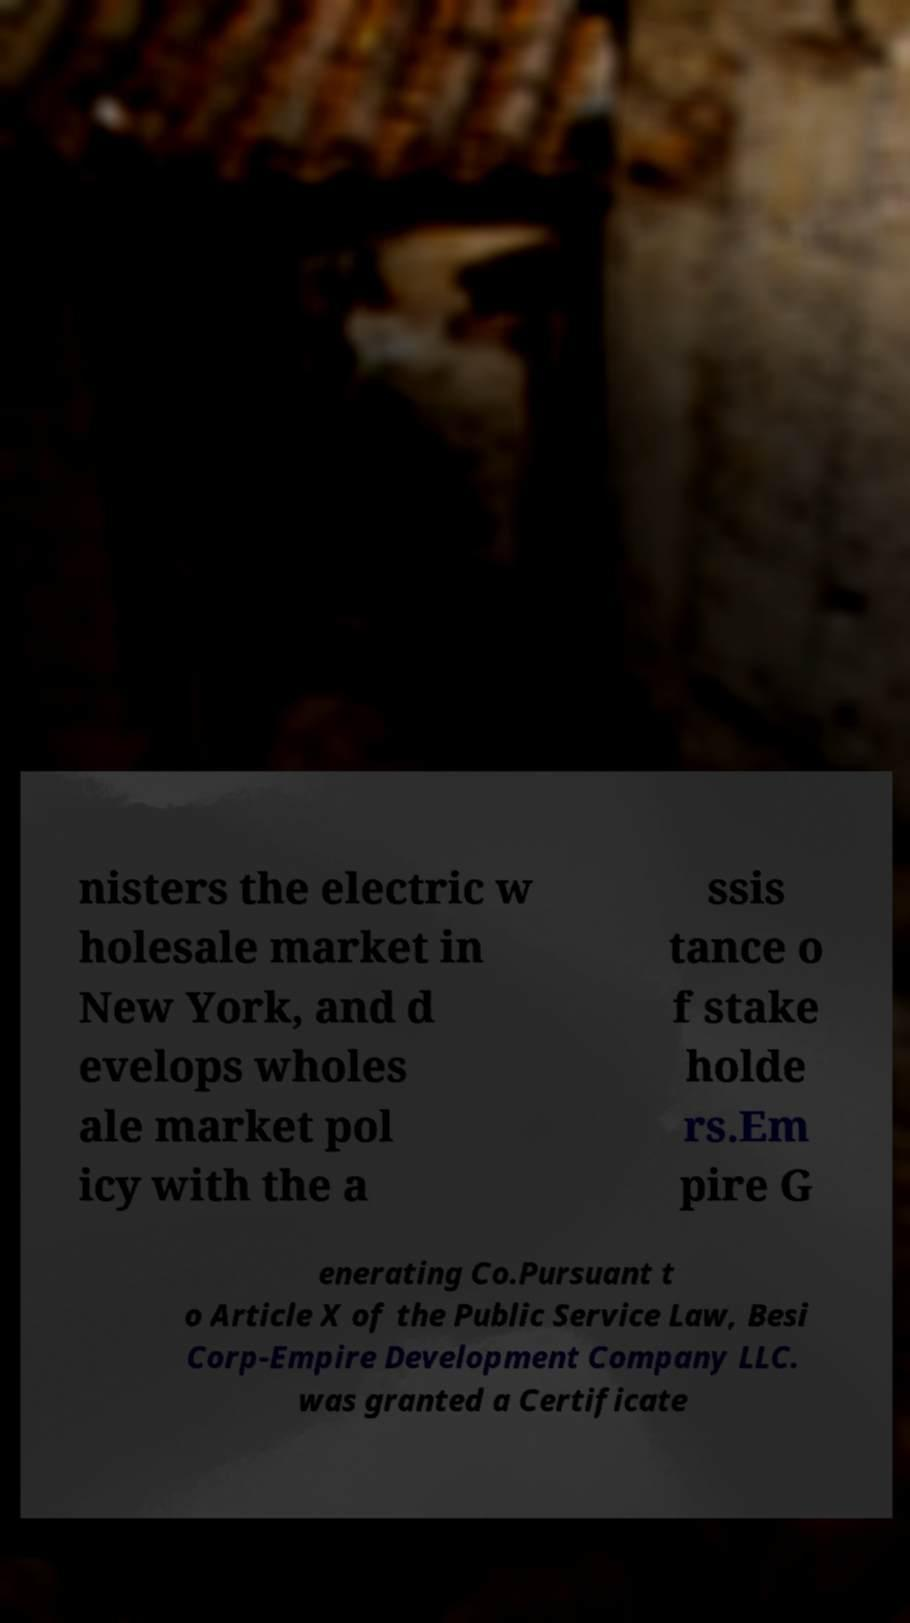Can you read and provide the text displayed in the image?This photo seems to have some interesting text. Can you extract and type it out for me? nisters the electric w holesale market in New York, and d evelops wholes ale market pol icy with the a ssis tance o f stake holde rs.Em pire G enerating Co.Pursuant t o Article X of the Public Service Law, Besi Corp-Empire Development Company LLC. was granted a Certificate 